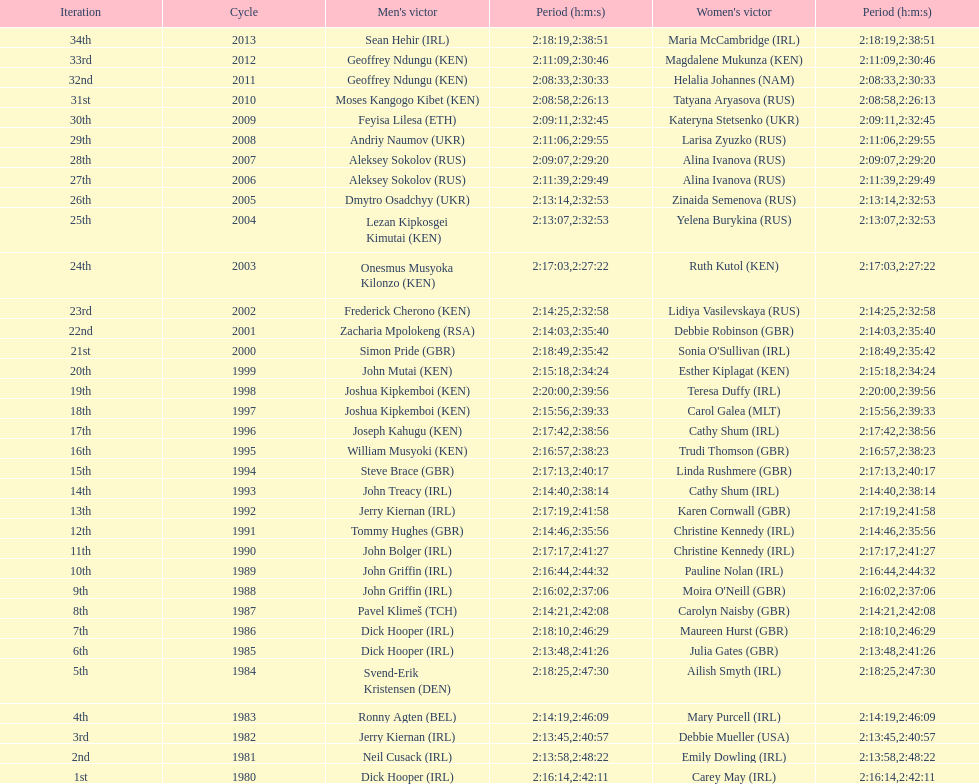Who won at least 3 times in the mens? Dick Hooper (IRL). 